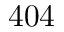<formula> <loc_0><loc_0><loc_500><loc_500>4 0 4</formula> 